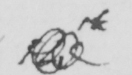Can you tell me what this handwritten text says? the 